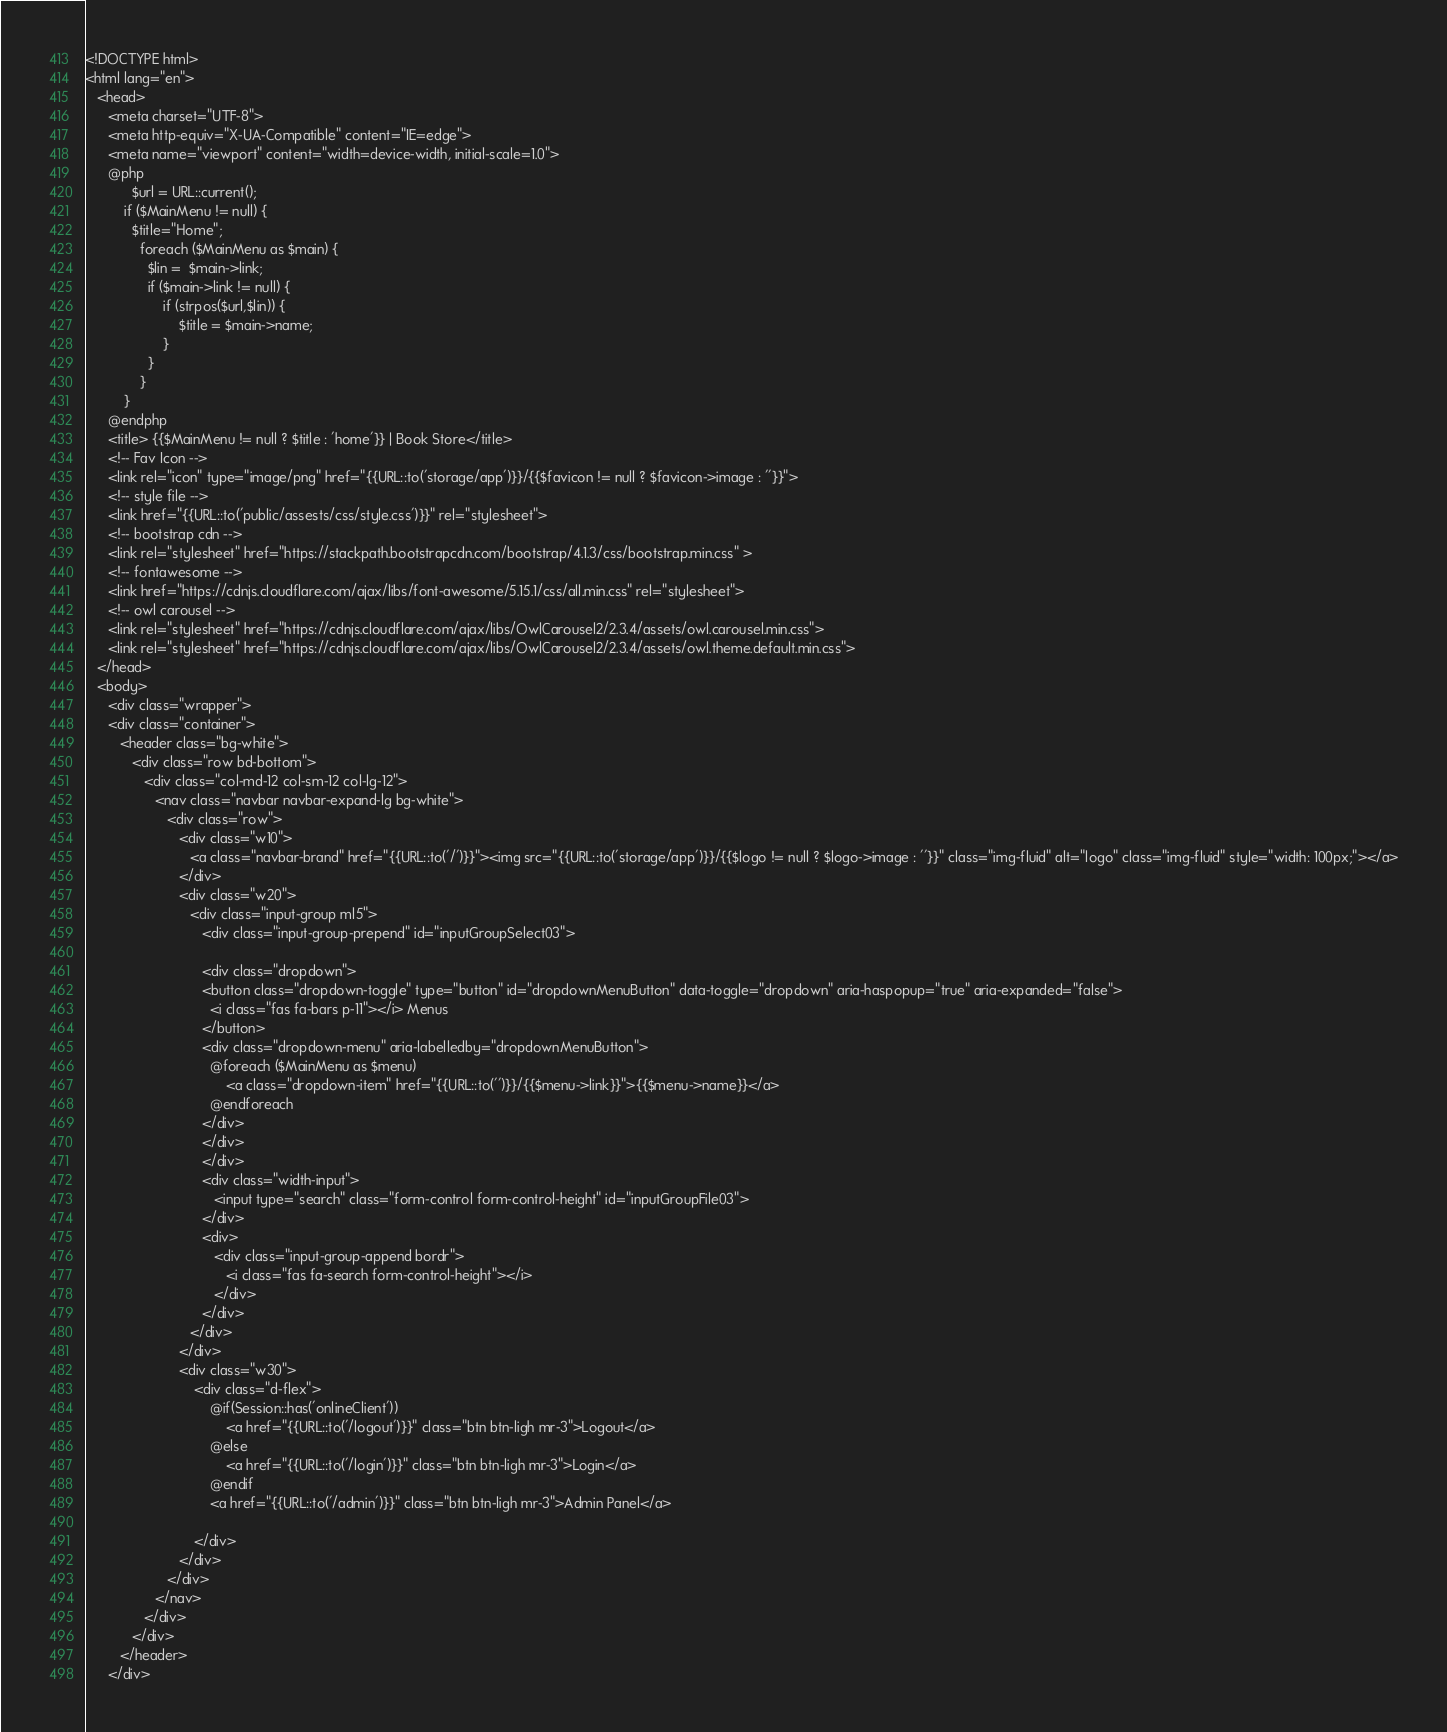Convert code to text. <code><loc_0><loc_0><loc_500><loc_500><_PHP_><!DOCTYPE html>
<html lang="en">
   <head>
      <meta charset="UTF-8">
      <meta http-equiv="X-UA-Compatible" content="IE=edge">
      <meta name="viewport" content="width=device-width, initial-scale=1.0">
      @php
            $url = URL::current();
          if ($MainMenu != null) {
            $title="Home";
              foreach ($MainMenu as $main) {
                $lin =  $main->link;
                if ($main->link != null) {
                    if (strpos($url,$lin)) {
                        $title = $main->name;
                    }
                }
              }
          }
      @endphp
      <title> {{$MainMenu != null ? $title : 'home'}} | Book Store</title>
      <!-- Fav Icon -->
      <link rel="icon" type="image/png" href="{{URL::to('storage/app')}}/{{$favicon != null ? $favicon->image : ''}}">
      <!-- style file -->
      <link href="{{URL::to('public/assests/css/style.css')}}" rel="stylesheet">
      <!-- bootstrap cdn -->
      <link rel="stylesheet" href="https://stackpath.bootstrapcdn.com/bootstrap/4.1.3/css/bootstrap.min.css" >
      <!-- fontawesome -->
      <link href="https://cdnjs.cloudflare.com/ajax/libs/font-awesome/5.15.1/css/all.min.css" rel="stylesheet">
      <!-- owl carousel -->
      <link rel="stylesheet" href="https://cdnjs.cloudflare.com/ajax/libs/OwlCarousel2/2.3.4/assets/owl.carousel.min.css">
      <link rel="stylesheet" href="https://cdnjs.cloudflare.com/ajax/libs/OwlCarousel2/2.3.4/assets/owl.theme.default.min.css">
   </head>
   <body>
      <div class="wrapper">
      <div class="container">
         <header class="bg-white">
            <div class="row bd-bottom">
               <div class="col-md-12 col-sm-12 col-lg-12">
                  <nav class="navbar navbar-expand-lg bg-white">
                     <div class="row">
                        <div class="w10">
                           <a class="navbar-brand" href="{{URL::to('/')}}"><img src="{{URL::to('storage/app')}}/{{$logo != null ? $logo->image : ''}}" class="img-fluid" alt="logo" class="img-fluid" style="width: 100px;"></a>
                        </div>
                        <div class="w20">
                           <div class="input-group ml5">
                              <div class="input-group-prepend" id="inputGroupSelect03">

                              <div class="dropdown">
                              <button class="dropdown-toggle" type="button" id="dropdownMenuButton" data-toggle="dropdown" aria-haspopup="true" aria-expanded="false">
                                <i class="fas fa-bars p-11"></i> Menus
                              </button>
                              <div class="dropdown-menu" aria-labelledby="dropdownMenuButton">
                                @foreach ($MainMenu as $menu)
                                    <a class="dropdown-item" href="{{URL::to('')}}/{{$menu->link}}">{{$menu->name}}</a>
                                @endforeach
                              </div>
                              </div>
                              </div>
                              <div class="width-input">
                                 <input type="search" class="form-control form-control-height" id="inputGroupFile03">
                              </div>
                              <div>
                                 <div class="input-group-append bordr">
                                    <i class="fas fa-search form-control-height"></i>
                                 </div>
                              </div>
                           </div>
                        </div>
                        <div class="w30">
                            <div class="d-flex">
                                @if(Session::has('onlineClient'))
                                    <a href="{{URL::to('/logout')}}" class="btn btn-ligh mr-3">Logout</a>
                                @else
                                    <a href="{{URL::to('/login')}}" class="btn btn-ligh mr-3">Login</a>
                                @endif
                                <a href="{{URL::to('/admin')}}" class="btn btn-ligh mr-3">Admin Panel</a>

                            </div>
                        </div>
                     </div>
                  </nav>
               </div>
            </div>
         </header>
      </div>


</code> 